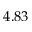<formula> <loc_0><loc_0><loc_500><loc_500>4 . 8 3</formula> 